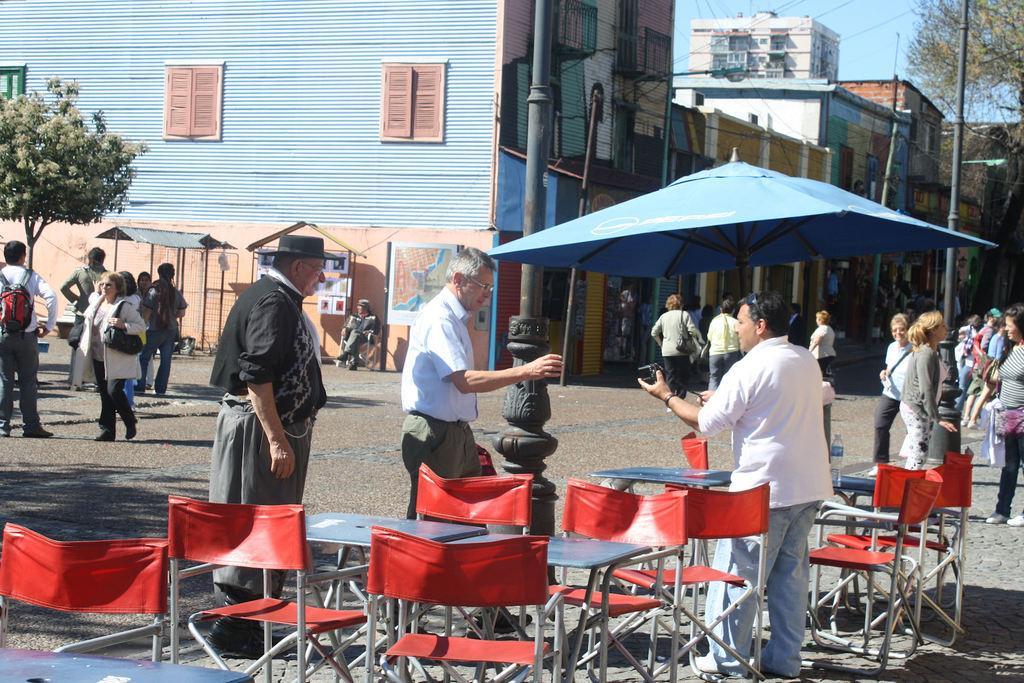How would you summarize this image in a sentence or two? In this image there are so many persons are standing on the road and their are some chair are there and behind the persons there is one building and tree and background is sunny. 